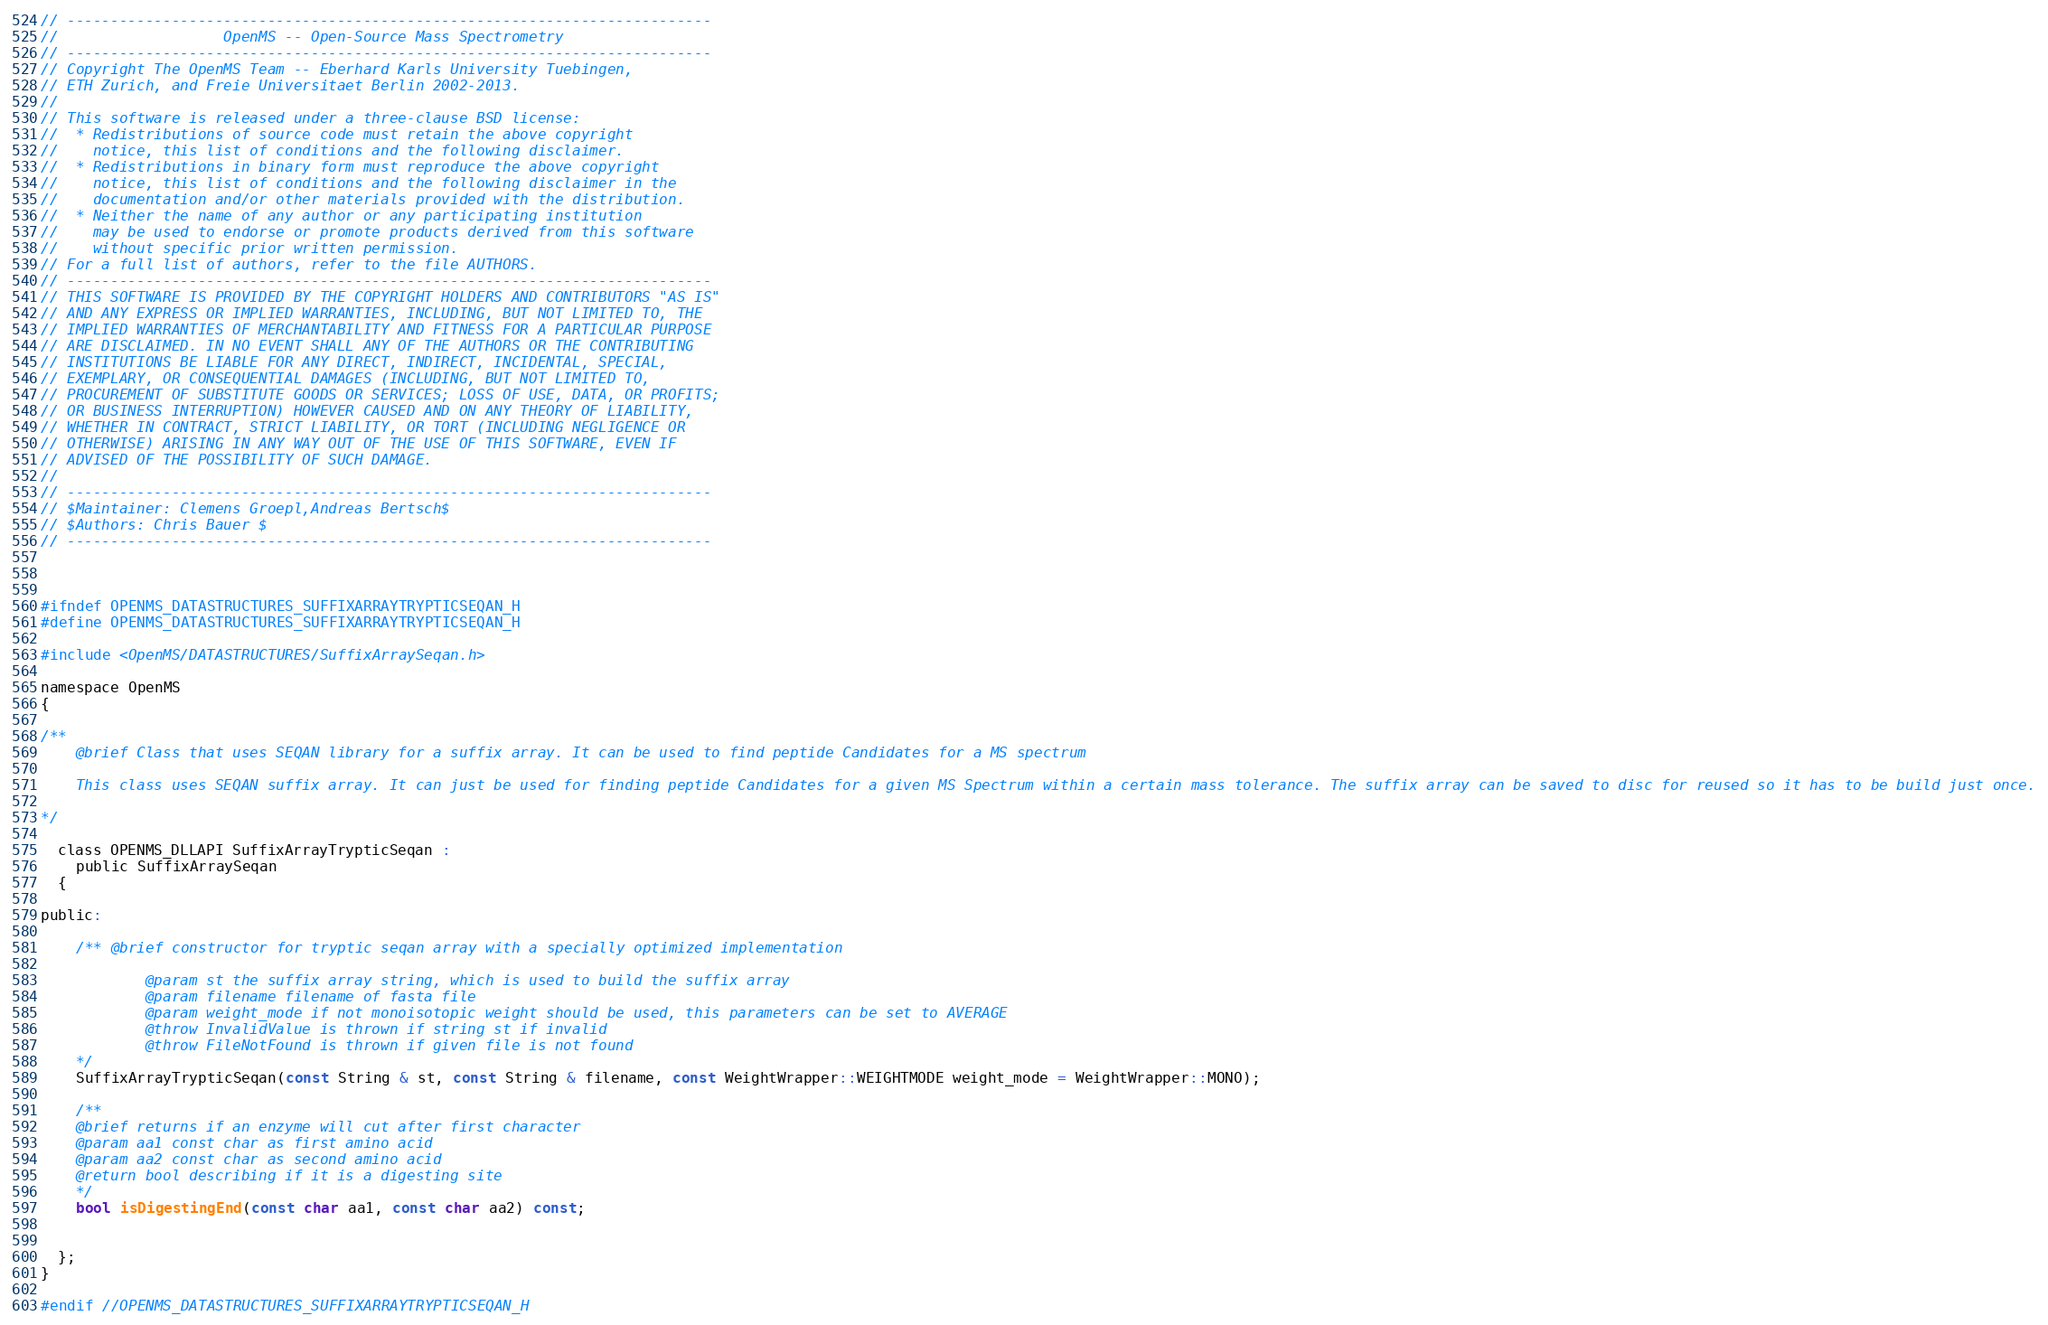Convert code to text. <code><loc_0><loc_0><loc_500><loc_500><_C_>// --------------------------------------------------------------------------
//                   OpenMS -- Open-Source Mass Spectrometry
// --------------------------------------------------------------------------
// Copyright The OpenMS Team -- Eberhard Karls University Tuebingen,
// ETH Zurich, and Freie Universitaet Berlin 2002-2013.
//
// This software is released under a three-clause BSD license:
//  * Redistributions of source code must retain the above copyright
//    notice, this list of conditions and the following disclaimer.
//  * Redistributions in binary form must reproduce the above copyright
//    notice, this list of conditions and the following disclaimer in the
//    documentation and/or other materials provided with the distribution.
//  * Neither the name of any author or any participating institution
//    may be used to endorse or promote products derived from this software
//    without specific prior written permission.
// For a full list of authors, refer to the file AUTHORS.
// --------------------------------------------------------------------------
// THIS SOFTWARE IS PROVIDED BY THE COPYRIGHT HOLDERS AND CONTRIBUTORS "AS IS"
// AND ANY EXPRESS OR IMPLIED WARRANTIES, INCLUDING, BUT NOT LIMITED TO, THE
// IMPLIED WARRANTIES OF MERCHANTABILITY AND FITNESS FOR A PARTICULAR PURPOSE
// ARE DISCLAIMED. IN NO EVENT SHALL ANY OF THE AUTHORS OR THE CONTRIBUTING
// INSTITUTIONS BE LIABLE FOR ANY DIRECT, INDIRECT, INCIDENTAL, SPECIAL,
// EXEMPLARY, OR CONSEQUENTIAL DAMAGES (INCLUDING, BUT NOT LIMITED TO,
// PROCUREMENT OF SUBSTITUTE GOODS OR SERVICES; LOSS OF USE, DATA, OR PROFITS;
// OR BUSINESS INTERRUPTION) HOWEVER CAUSED AND ON ANY THEORY OF LIABILITY,
// WHETHER IN CONTRACT, STRICT LIABILITY, OR TORT (INCLUDING NEGLIGENCE OR
// OTHERWISE) ARISING IN ANY WAY OUT OF THE USE OF THIS SOFTWARE, EVEN IF
// ADVISED OF THE POSSIBILITY OF SUCH DAMAGE.
//
// --------------------------------------------------------------------------
// $Maintainer: Clemens Groepl,Andreas Bertsch$
// $Authors: Chris Bauer $
// --------------------------------------------------------------------------



#ifndef OPENMS_DATASTRUCTURES_SUFFIXARRAYTRYPTICSEQAN_H
#define OPENMS_DATASTRUCTURES_SUFFIXARRAYTRYPTICSEQAN_H

#include <OpenMS/DATASTRUCTURES/SuffixArraySeqan.h>

namespace OpenMS
{

/**
    @brief Class that uses SEQAN library for a suffix array. It can be used to find peptide Candidates for a MS spectrum

    This class uses SEQAN suffix array. It can just be used for finding peptide Candidates for a given MS Spectrum within a certain mass tolerance. The suffix array can be saved to disc for reused so it has to be build just once.

*/

  class OPENMS_DLLAPI SuffixArrayTrypticSeqan :
    public SuffixArraySeqan
  {

public:

    /** @brief constructor for tryptic seqan array with a specially optimized implementation

            @param st the suffix array string, which is used to build the suffix array
            @param filename filename of fasta file
            @param weight_mode if not monoisotopic weight should be used, this parameters can be set to AVERAGE
            @throw InvalidValue is thrown if string st if invalid
            @throw FileNotFound is thrown if given file is not found
    */
    SuffixArrayTrypticSeqan(const String & st, const String & filename, const WeightWrapper::WEIGHTMODE weight_mode = WeightWrapper::MONO);

    /**
    @brief returns if an enzyme will cut after first character
    @param aa1 const char as first amino acid
    @param aa2 const char as second amino acid
    @return bool describing if it is a digesting site
    */
    bool isDigestingEnd(const char aa1, const char aa2) const;


  };
}

#endif //OPENMS_DATASTRUCTURES_SUFFIXARRAYTRYPTICSEQAN_H
</code> 